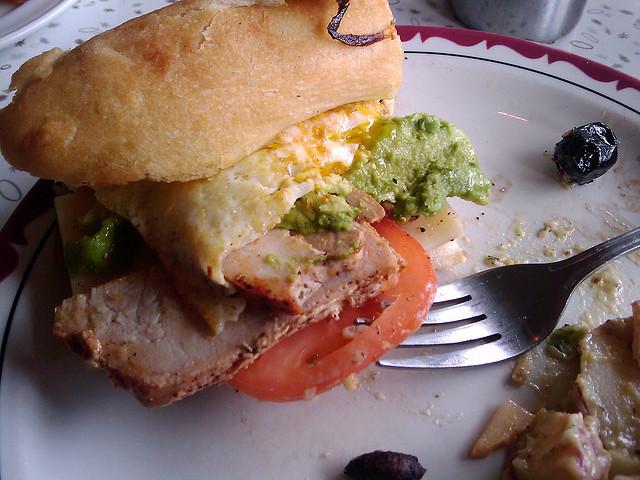What utensil is shown?
Keep it brief. Fork. What is the green stuff called?
Answer briefly. Guacamole. Is this fast food?
Write a very short answer. No. Is there lettuce on the sandwich?
Keep it brief. No. 